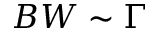<formula> <loc_0><loc_0><loc_500><loc_500>B W \sim \Gamma</formula> 